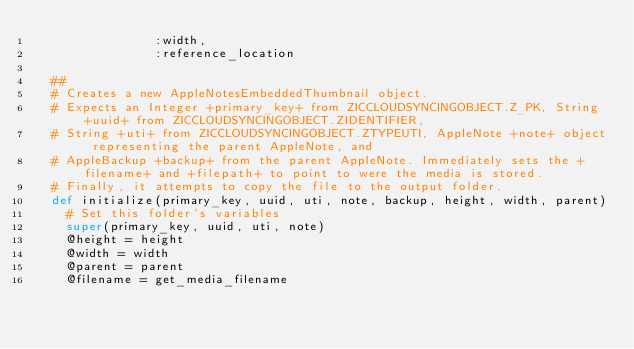Convert code to text. <code><loc_0><loc_0><loc_500><loc_500><_Ruby_>                :width,
                :reference_location

  ##
  # Creates a new AppleNotesEmbeddedThumbnail object.
  # Expects an Integer +primary_key+ from ZICCLOUDSYNCINGOBJECT.Z_PK, String +uuid+ from ZICCLOUDSYNCINGOBJECT.ZIDENTIFIER,
  # String +uti+ from ZICCLOUDSYNCINGOBJECT.ZTYPEUTI, AppleNote +note+ object representing the parent AppleNote, and
  # AppleBackup +backup+ from the parent AppleNote. Immediately sets the +filename+ and +filepath+ to point to were the media is stored.
  # Finally, it attempts to copy the file to the output folder.
  def initialize(primary_key, uuid, uti, note, backup, height, width, parent)
    # Set this folder's variables
    super(primary_key, uuid, uti, note)
    @height = height
    @width = width
    @parent = parent
    @filename = get_media_filename</code> 